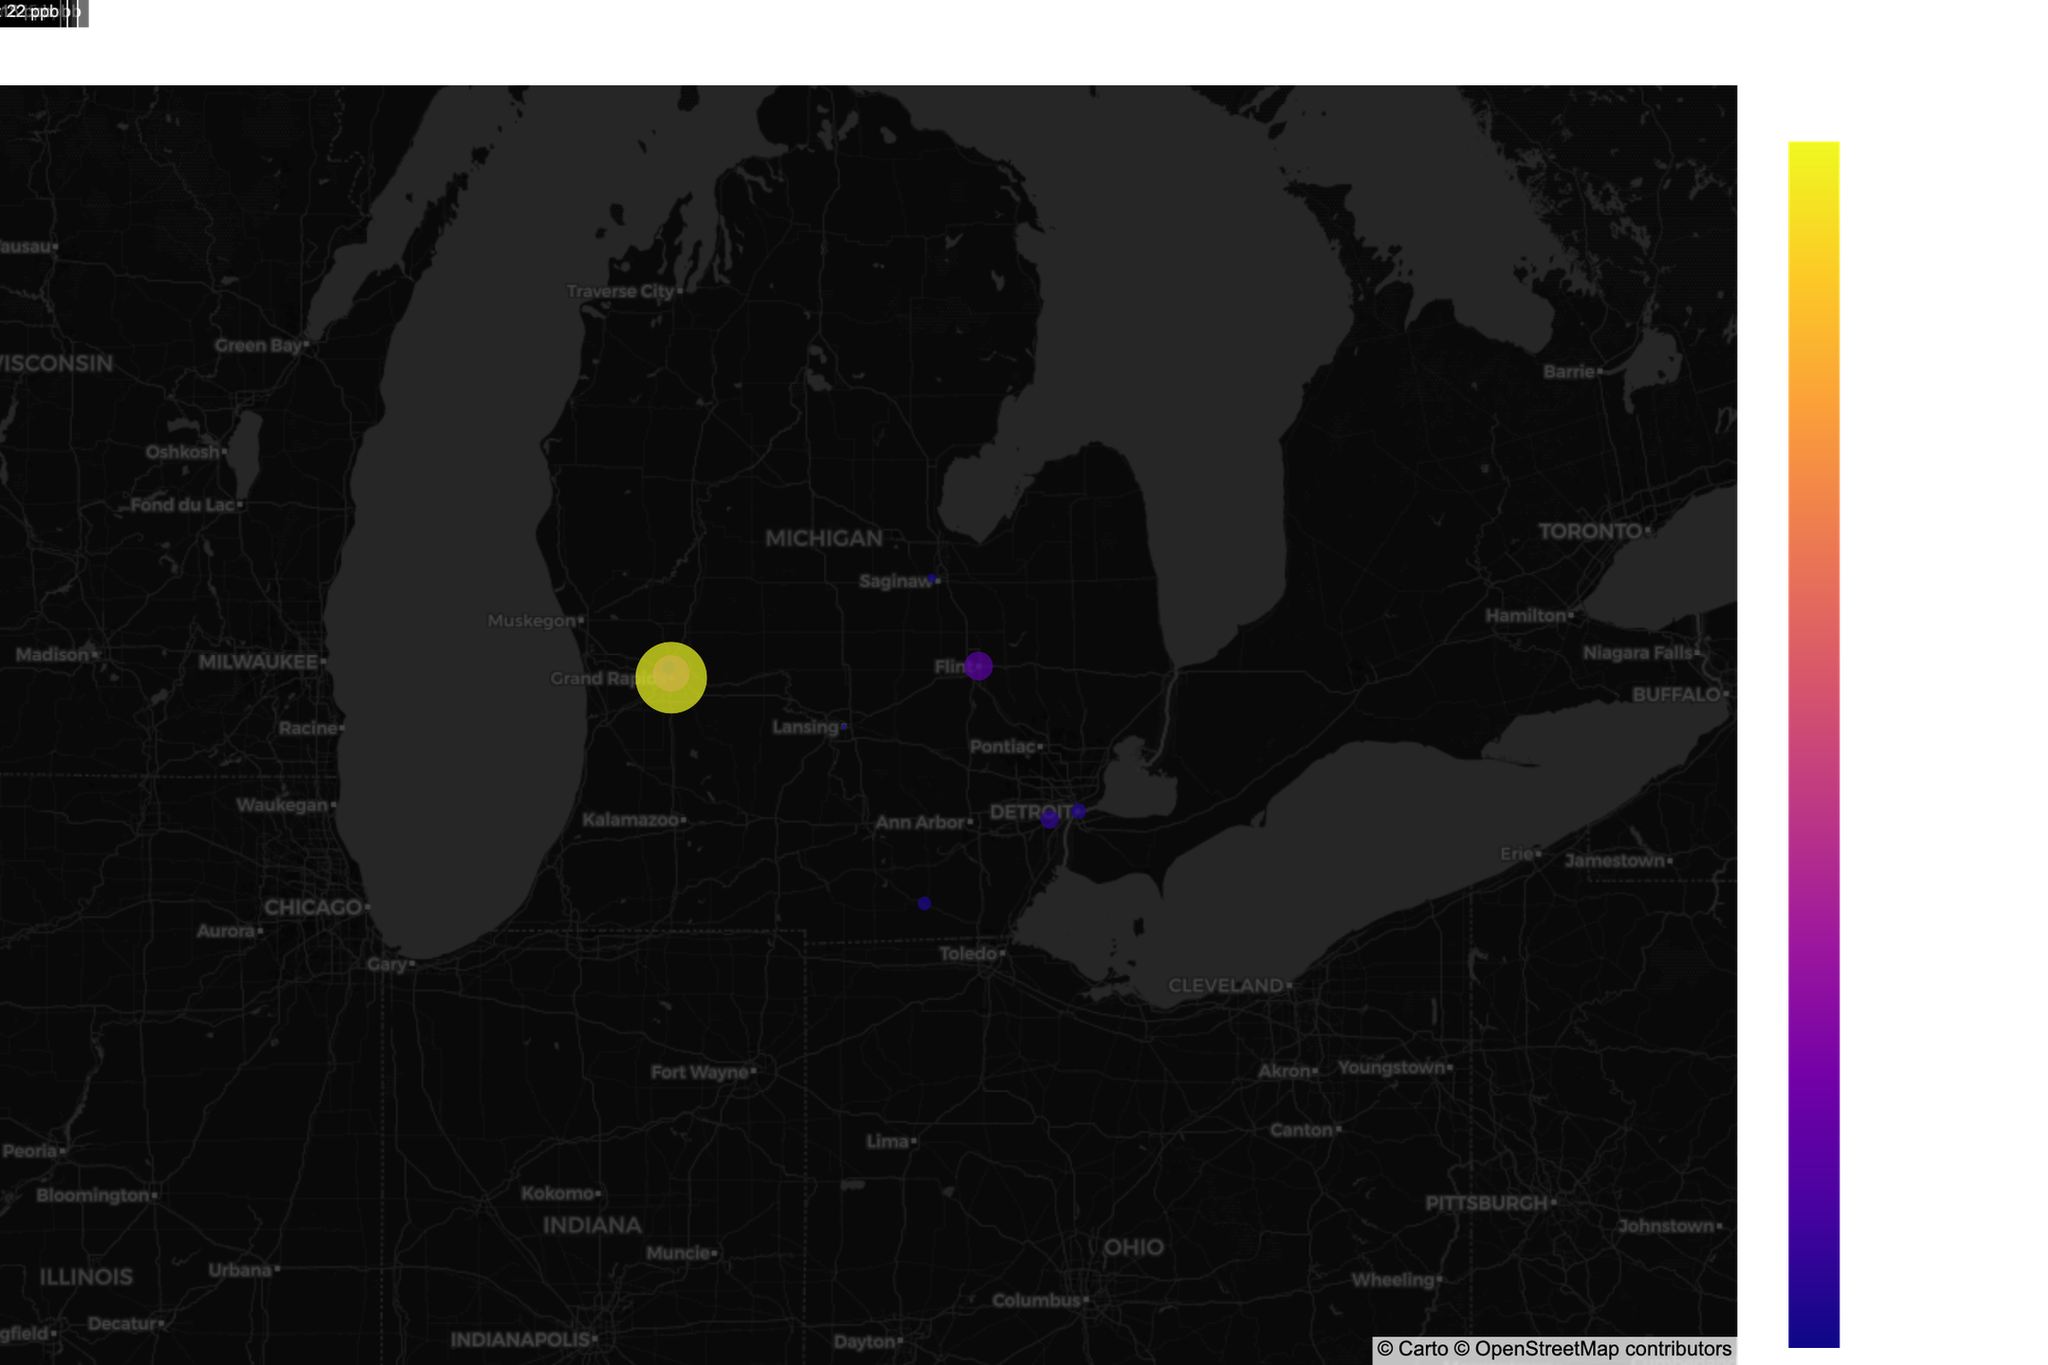What is the title of the figure? The title of the figure is typically displayed prominently at the top of the plot. In this case, the title is "Water Contamination Levels Near Chemical Plants in Michigan."
Answer: Water Contamination Levels Near Chemical Plants in Michigan How many data points are shown on the map? To determine the number of data points, count the individual markers on the map. Each marker represents a contamination measurement. There are 9 markers.
Answer: 9 Which location has the highest contamination concentration? Review the concentration_ppb values associated with each marker. The location with the highest value is Ada, with a concentration of 450 ppb.
Answer: Ada Compare the contaminant concentration at Grand Rapids and Detroit. Which is higher and by how much? Grand Rapids has a PFAS concentration of 120 ppb, and Detroit has a Benzene concentration of 32 ppb. The difference is 120 - 32 = 88 ppb.
Answer: Grand Rapids by 88 ppb What contaminant is detected near Rockford, and what is its concentration? Look at the information displayed for the marker near Rockford. The contaminant is Lead with a concentration of 15 ppb.
Answer: Lead, 15 ppb What is the average distance from the chemical plants for all locations? Sum the distances from the chemical plants for all locations and divide by the number of locations. (2.3 + 1.8 + 3.5 + 0.9 + 4.1 + 1.2 + 2.7 + 1.5 + 0.6) / 9 = 18.6 / 9 = 2.07 km.
Answer: 2.07 km Which location is closest to its chemical plant? Find the smallest Distance_km value among the locations. It is Detroit River, with a distance of 0.6 km.
Answer: Detroit River What types of contaminants are present near chemical plants in Michigan? Examine the labels or information associated with each marker to list all contaminants detected: PFAS, Lead, Benzene, Dioxins, Mercury, Phosphates, Chromium, PCBs, Arsenic.
Answer: PFAS, Lead, Benzene, Dioxins, Mercury, Phosphates, Chromium, PCBs, Arsenic Which location has the lowest contamination level, and what is the contaminant? Identify the location with the smallest concentration_ppb value. Midland has the lowest contamination level with a concentration of 8 ppb and the contaminant is Dioxins.
Answer: Midland, Dioxins 